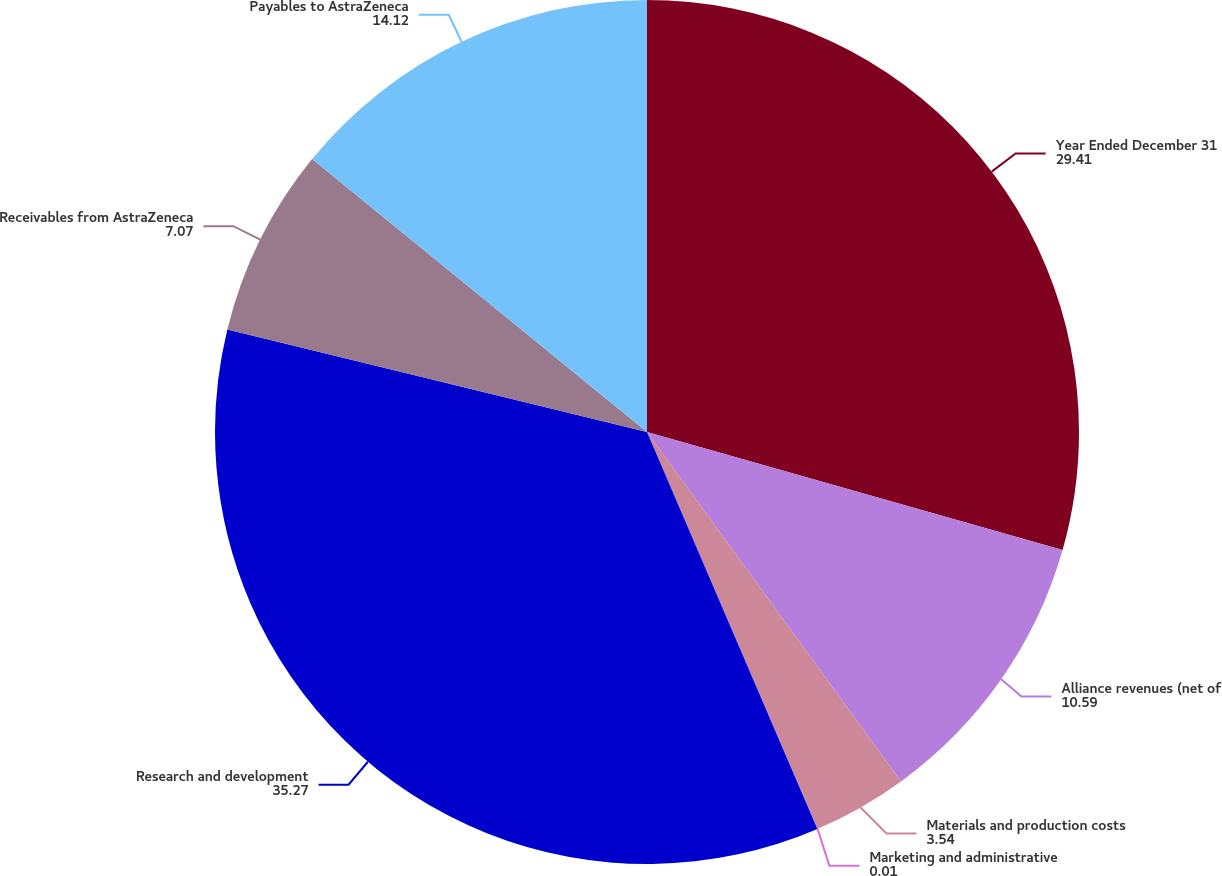<chart> <loc_0><loc_0><loc_500><loc_500><pie_chart><fcel>Year Ended December 31<fcel>Alliance revenues (net of<fcel>Materials and production costs<fcel>Marketing and administrative<fcel>Research and development<fcel>Receivables from AstraZeneca<fcel>Payables to AstraZeneca<nl><fcel>29.41%<fcel>10.59%<fcel>3.54%<fcel>0.01%<fcel>35.27%<fcel>7.07%<fcel>14.12%<nl></chart> 